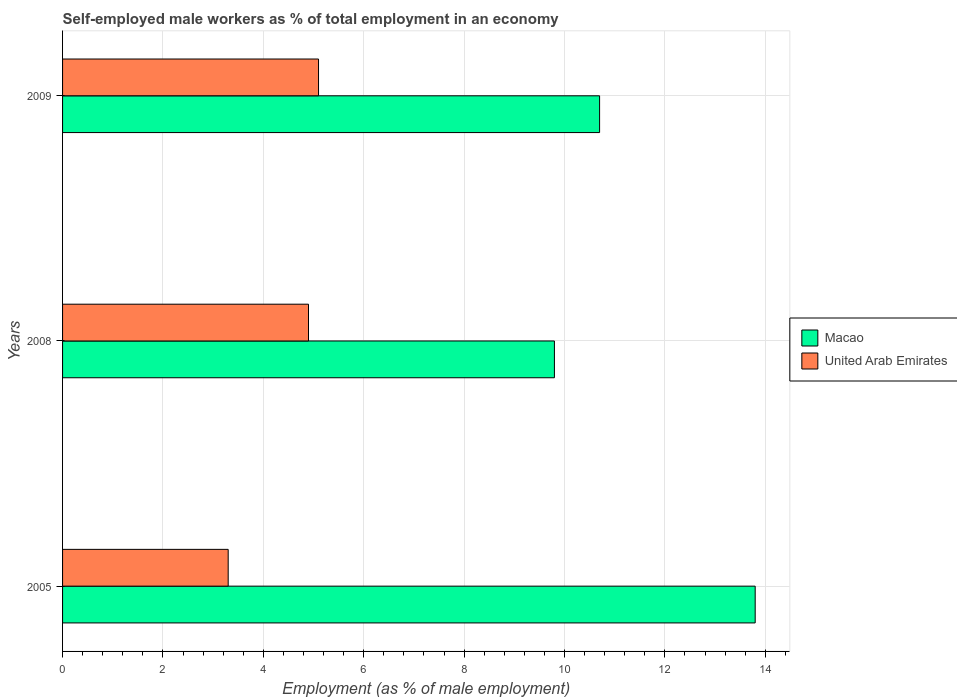Are the number of bars on each tick of the Y-axis equal?
Your answer should be compact. Yes. How many bars are there on the 3rd tick from the top?
Give a very brief answer. 2. How many bars are there on the 2nd tick from the bottom?
Offer a very short reply. 2. In how many cases, is the number of bars for a given year not equal to the number of legend labels?
Provide a succinct answer. 0. What is the percentage of self-employed male workers in United Arab Emirates in 2005?
Keep it short and to the point. 3.3. Across all years, what is the maximum percentage of self-employed male workers in United Arab Emirates?
Your answer should be very brief. 5.1. Across all years, what is the minimum percentage of self-employed male workers in United Arab Emirates?
Give a very brief answer. 3.3. In which year was the percentage of self-employed male workers in Macao maximum?
Your answer should be very brief. 2005. In which year was the percentage of self-employed male workers in United Arab Emirates minimum?
Your answer should be compact. 2005. What is the total percentage of self-employed male workers in United Arab Emirates in the graph?
Ensure brevity in your answer.  13.3. What is the difference between the percentage of self-employed male workers in Macao in 2005 and that in 2009?
Your answer should be very brief. 3.1. What is the difference between the percentage of self-employed male workers in Macao in 2005 and the percentage of self-employed male workers in United Arab Emirates in 2008?
Your answer should be very brief. 8.9. What is the average percentage of self-employed male workers in United Arab Emirates per year?
Ensure brevity in your answer.  4.43. In the year 2008, what is the difference between the percentage of self-employed male workers in United Arab Emirates and percentage of self-employed male workers in Macao?
Make the answer very short. -4.9. In how many years, is the percentage of self-employed male workers in Macao greater than 10 %?
Offer a terse response. 2. What is the ratio of the percentage of self-employed male workers in Macao in 2005 to that in 2008?
Ensure brevity in your answer.  1.41. Is the percentage of self-employed male workers in Macao in 2005 less than that in 2008?
Provide a succinct answer. No. What is the difference between the highest and the second highest percentage of self-employed male workers in Macao?
Your answer should be compact. 3.1. What is the difference between the highest and the lowest percentage of self-employed male workers in Macao?
Make the answer very short. 4. In how many years, is the percentage of self-employed male workers in Macao greater than the average percentage of self-employed male workers in Macao taken over all years?
Offer a very short reply. 1. What does the 1st bar from the top in 2008 represents?
Offer a very short reply. United Arab Emirates. What does the 2nd bar from the bottom in 2009 represents?
Your response must be concise. United Arab Emirates. Are all the bars in the graph horizontal?
Your answer should be compact. Yes. How many years are there in the graph?
Offer a terse response. 3. What is the difference between two consecutive major ticks on the X-axis?
Make the answer very short. 2. Are the values on the major ticks of X-axis written in scientific E-notation?
Offer a very short reply. No. Does the graph contain any zero values?
Offer a very short reply. No. Does the graph contain grids?
Offer a very short reply. Yes. How many legend labels are there?
Offer a very short reply. 2. What is the title of the graph?
Offer a very short reply. Self-employed male workers as % of total employment in an economy. Does "Paraguay" appear as one of the legend labels in the graph?
Your answer should be compact. No. What is the label or title of the X-axis?
Make the answer very short. Employment (as % of male employment). What is the label or title of the Y-axis?
Ensure brevity in your answer.  Years. What is the Employment (as % of male employment) in Macao in 2005?
Your response must be concise. 13.8. What is the Employment (as % of male employment) of United Arab Emirates in 2005?
Give a very brief answer. 3.3. What is the Employment (as % of male employment) of Macao in 2008?
Give a very brief answer. 9.8. What is the Employment (as % of male employment) in United Arab Emirates in 2008?
Offer a very short reply. 4.9. What is the Employment (as % of male employment) in Macao in 2009?
Offer a very short reply. 10.7. What is the Employment (as % of male employment) of United Arab Emirates in 2009?
Your response must be concise. 5.1. Across all years, what is the maximum Employment (as % of male employment) in Macao?
Your answer should be very brief. 13.8. Across all years, what is the maximum Employment (as % of male employment) of United Arab Emirates?
Your response must be concise. 5.1. Across all years, what is the minimum Employment (as % of male employment) in Macao?
Give a very brief answer. 9.8. Across all years, what is the minimum Employment (as % of male employment) in United Arab Emirates?
Make the answer very short. 3.3. What is the total Employment (as % of male employment) in Macao in the graph?
Your response must be concise. 34.3. What is the total Employment (as % of male employment) in United Arab Emirates in the graph?
Keep it short and to the point. 13.3. What is the difference between the Employment (as % of male employment) in Macao in 2005 and that in 2008?
Your answer should be compact. 4. What is the difference between the Employment (as % of male employment) of United Arab Emirates in 2005 and that in 2008?
Offer a very short reply. -1.6. What is the difference between the Employment (as % of male employment) in Macao in 2005 and that in 2009?
Make the answer very short. 3.1. What is the difference between the Employment (as % of male employment) of United Arab Emirates in 2005 and that in 2009?
Provide a short and direct response. -1.8. What is the difference between the Employment (as % of male employment) of United Arab Emirates in 2008 and that in 2009?
Ensure brevity in your answer.  -0.2. What is the difference between the Employment (as % of male employment) in Macao in 2005 and the Employment (as % of male employment) in United Arab Emirates in 2009?
Provide a short and direct response. 8.7. What is the difference between the Employment (as % of male employment) of Macao in 2008 and the Employment (as % of male employment) of United Arab Emirates in 2009?
Give a very brief answer. 4.7. What is the average Employment (as % of male employment) in Macao per year?
Give a very brief answer. 11.43. What is the average Employment (as % of male employment) of United Arab Emirates per year?
Your response must be concise. 4.43. In the year 2005, what is the difference between the Employment (as % of male employment) in Macao and Employment (as % of male employment) in United Arab Emirates?
Provide a succinct answer. 10.5. What is the ratio of the Employment (as % of male employment) of Macao in 2005 to that in 2008?
Your response must be concise. 1.41. What is the ratio of the Employment (as % of male employment) of United Arab Emirates in 2005 to that in 2008?
Make the answer very short. 0.67. What is the ratio of the Employment (as % of male employment) in Macao in 2005 to that in 2009?
Ensure brevity in your answer.  1.29. What is the ratio of the Employment (as % of male employment) of United Arab Emirates in 2005 to that in 2009?
Give a very brief answer. 0.65. What is the ratio of the Employment (as % of male employment) in Macao in 2008 to that in 2009?
Give a very brief answer. 0.92. What is the ratio of the Employment (as % of male employment) of United Arab Emirates in 2008 to that in 2009?
Give a very brief answer. 0.96. What is the difference between the highest and the second highest Employment (as % of male employment) in Macao?
Offer a very short reply. 3.1. 